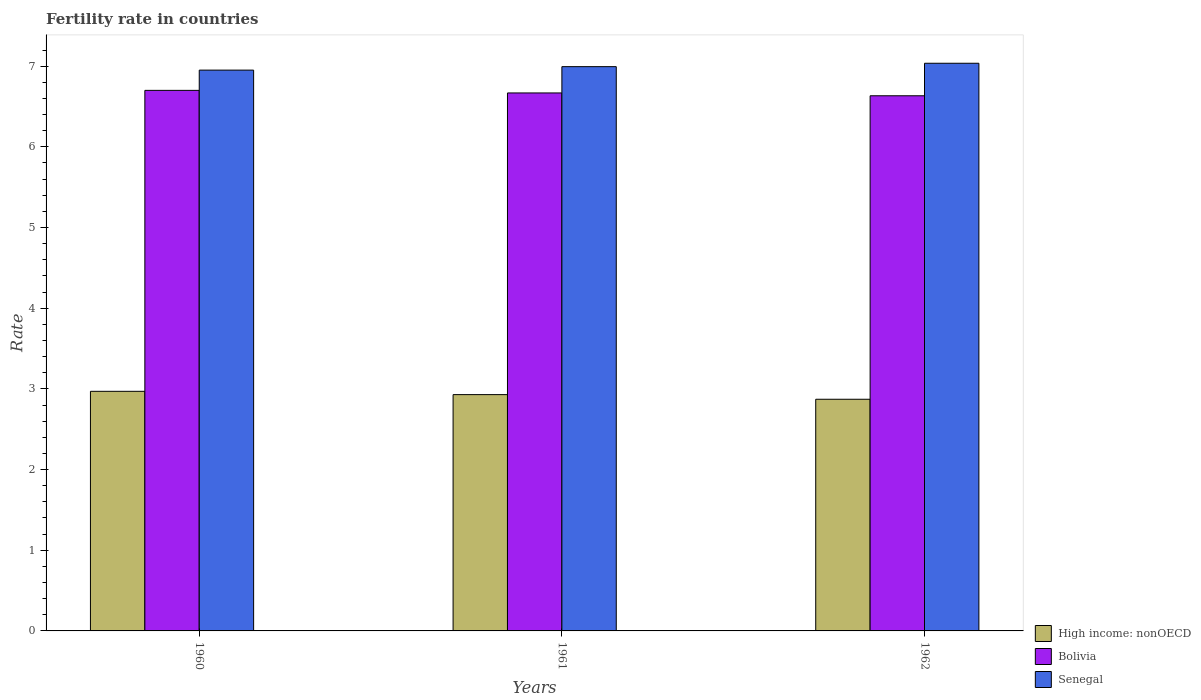How many different coloured bars are there?
Make the answer very short. 3. How many bars are there on the 1st tick from the left?
Make the answer very short. 3. How many bars are there on the 3rd tick from the right?
Give a very brief answer. 3. What is the fertility rate in Senegal in 1960?
Make the answer very short. 6.95. Across all years, what is the maximum fertility rate in Bolivia?
Provide a succinct answer. 6.7. Across all years, what is the minimum fertility rate in High income: nonOECD?
Ensure brevity in your answer.  2.87. What is the total fertility rate in Bolivia in the graph?
Your answer should be very brief. 20. What is the difference between the fertility rate in Senegal in 1960 and that in 1962?
Keep it short and to the point. -0.08. What is the difference between the fertility rate in Senegal in 1962 and the fertility rate in High income: nonOECD in 1960?
Your answer should be compact. 4.07. What is the average fertility rate in Bolivia per year?
Offer a very short reply. 6.67. In the year 1962, what is the difference between the fertility rate in High income: nonOECD and fertility rate in Senegal?
Make the answer very short. -4.16. In how many years, is the fertility rate in Bolivia greater than 3.6?
Keep it short and to the point. 3. What is the ratio of the fertility rate in Bolivia in 1960 to that in 1961?
Ensure brevity in your answer.  1. What is the difference between the highest and the second highest fertility rate in High income: nonOECD?
Keep it short and to the point. 0.04. What is the difference between the highest and the lowest fertility rate in Bolivia?
Your answer should be very brief. 0.07. In how many years, is the fertility rate in High income: nonOECD greater than the average fertility rate in High income: nonOECD taken over all years?
Give a very brief answer. 2. What does the 3rd bar from the left in 1960 represents?
Provide a succinct answer. Senegal. What does the 2nd bar from the right in 1962 represents?
Your answer should be very brief. Bolivia. Is it the case that in every year, the sum of the fertility rate in Bolivia and fertility rate in Senegal is greater than the fertility rate in High income: nonOECD?
Your answer should be very brief. Yes. How many bars are there?
Offer a very short reply. 9. Are all the bars in the graph horizontal?
Keep it short and to the point. No. How many years are there in the graph?
Your answer should be very brief. 3. Does the graph contain grids?
Ensure brevity in your answer.  No. Where does the legend appear in the graph?
Your answer should be very brief. Bottom right. How many legend labels are there?
Offer a terse response. 3. How are the legend labels stacked?
Make the answer very short. Vertical. What is the title of the graph?
Offer a very short reply. Fertility rate in countries. Does "Jordan" appear as one of the legend labels in the graph?
Provide a short and direct response. No. What is the label or title of the Y-axis?
Offer a terse response. Rate. What is the Rate of High income: nonOECD in 1960?
Your answer should be very brief. 2.97. What is the Rate in Bolivia in 1960?
Your answer should be very brief. 6.7. What is the Rate of Senegal in 1960?
Your response must be concise. 6.95. What is the Rate in High income: nonOECD in 1961?
Keep it short and to the point. 2.93. What is the Rate in Bolivia in 1961?
Keep it short and to the point. 6.67. What is the Rate of Senegal in 1961?
Provide a succinct answer. 6.99. What is the Rate of High income: nonOECD in 1962?
Your answer should be very brief. 2.87. What is the Rate in Bolivia in 1962?
Offer a terse response. 6.63. What is the Rate of Senegal in 1962?
Ensure brevity in your answer.  7.04. Across all years, what is the maximum Rate of High income: nonOECD?
Provide a succinct answer. 2.97. Across all years, what is the maximum Rate of Bolivia?
Provide a short and direct response. 6.7. Across all years, what is the maximum Rate in Senegal?
Offer a terse response. 7.04. Across all years, what is the minimum Rate in High income: nonOECD?
Ensure brevity in your answer.  2.87. Across all years, what is the minimum Rate in Bolivia?
Your response must be concise. 6.63. Across all years, what is the minimum Rate in Senegal?
Ensure brevity in your answer.  6.95. What is the total Rate in High income: nonOECD in the graph?
Provide a short and direct response. 8.77. What is the total Rate of Bolivia in the graph?
Your response must be concise. 20. What is the total Rate in Senegal in the graph?
Make the answer very short. 20.98. What is the difference between the Rate in High income: nonOECD in 1960 and that in 1961?
Provide a short and direct response. 0.04. What is the difference between the Rate in Bolivia in 1960 and that in 1961?
Provide a succinct answer. 0.03. What is the difference between the Rate of Senegal in 1960 and that in 1961?
Your answer should be compact. -0.04. What is the difference between the Rate in High income: nonOECD in 1960 and that in 1962?
Provide a succinct answer. 0.1. What is the difference between the Rate of Bolivia in 1960 and that in 1962?
Give a very brief answer. 0.07. What is the difference between the Rate of Senegal in 1960 and that in 1962?
Offer a very short reply. -0.09. What is the difference between the Rate in High income: nonOECD in 1961 and that in 1962?
Your response must be concise. 0.06. What is the difference between the Rate of Bolivia in 1961 and that in 1962?
Offer a terse response. 0.04. What is the difference between the Rate in Senegal in 1961 and that in 1962?
Keep it short and to the point. -0.04. What is the difference between the Rate in High income: nonOECD in 1960 and the Rate in Bolivia in 1961?
Your answer should be very brief. -3.7. What is the difference between the Rate in High income: nonOECD in 1960 and the Rate in Senegal in 1961?
Offer a very short reply. -4.02. What is the difference between the Rate in Bolivia in 1960 and the Rate in Senegal in 1961?
Make the answer very short. -0.29. What is the difference between the Rate of High income: nonOECD in 1960 and the Rate of Bolivia in 1962?
Provide a succinct answer. -3.66. What is the difference between the Rate in High income: nonOECD in 1960 and the Rate in Senegal in 1962?
Your response must be concise. -4.07. What is the difference between the Rate of Bolivia in 1960 and the Rate of Senegal in 1962?
Offer a very short reply. -0.34. What is the difference between the Rate of High income: nonOECD in 1961 and the Rate of Bolivia in 1962?
Your response must be concise. -3.7. What is the difference between the Rate in High income: nonOECD in 1961 and the Rate in Senegal in 1962?
Make the answer very short. -4.11. What is the difference between the Rate in Bolivia in 1961 and the Rate in Senegal in 1962?
Make the answer very short. -0.37. What is the average Rate of High income: nonOECD per year?
Your response must be concise. 2.92. What is the average Rate in Bolivia per year?
Offer a terse response. 6.67. What is the average Rate in Senegal per year?
Offer a very short reply. 6.99. In the year 1960, what is the difference between the Rate of High income: nonOECD and Rate of Bolivia?
Your answer should be compact. -3.73. In the year 1960, what is the difference between the Rate of High income: nonOECD and Rate of Senegal?
Provide a short and direct response. -3.98. In the year 1960, what is the difference between the Rate of Bolivia and Rate of Senegal?
Offer a terse response. -0.25. In the year 1961, what is the difference between the Rate in High income: nonOECD and Rate in Bolivia?
Provide a succinct answer. -3.74. In the year 1961, what is the difference between the Rate in High income: nonOECD and Rate in Senegal?
Offer a very short reply. -4.07. In the year 1961, what is the difference between the Rate of Bolivia and Rate of Senegal?
Your response must be concise. -0.33. In the year 1962, what is the difference between the Rate of High income: nonOECD and Rate of Bolivia?
Give a very brief answer. -3.76. In the year 1962, what is the difference between the Rate in High income: nonOECD and Rate in Senegal?
Your response must be concise. -4.16. In the year 1962, what is the difference between the Rate of Bolivia and Rate of Senegal?
Keep it short and to the point. -0.4. What is the ratio of the Rate of High income: nonOECD in 1960 to that in 1961?
Offer a very short reply. 1.01. What is the ratio of the Rate in Senegal in 1960 to that in 1961?
Make the answer very short. 0.99. What is the ratio of the Rate of High income: nonOECD in 1960 to that in 1962?
Offer a terse response. 1.03. What is the ratio of the Rate of Senegal in 1960 to that in 1962?
Give a very brief answer. 0.99. What is the ratio of the Rate of Senegal in 1961 to that in 1962?
Your answer should be compact. 0.99. What is the difference between the highest and the second highest Rate of High income: nonOECD?
Offer a terse response. 0.04. What is the difference between the highest and the second highest Rate in Bolivia?
Offer a terse response. 0.03. What is the difference between the highest and the second highest Rate in Senegal?
Ensure brevity in your answer.  0.04. What is the difference between the highest and the lowest Rate in High income: nonOECD?
Offer a very short reply. 0.1. What is the difference between the highest and the lowest Rate in Bolivia?
Provide a succinct answer. 0.07. What is the difference between the highest and the lowest Rate in Senegal?
Offer a terse response. 0.09. 